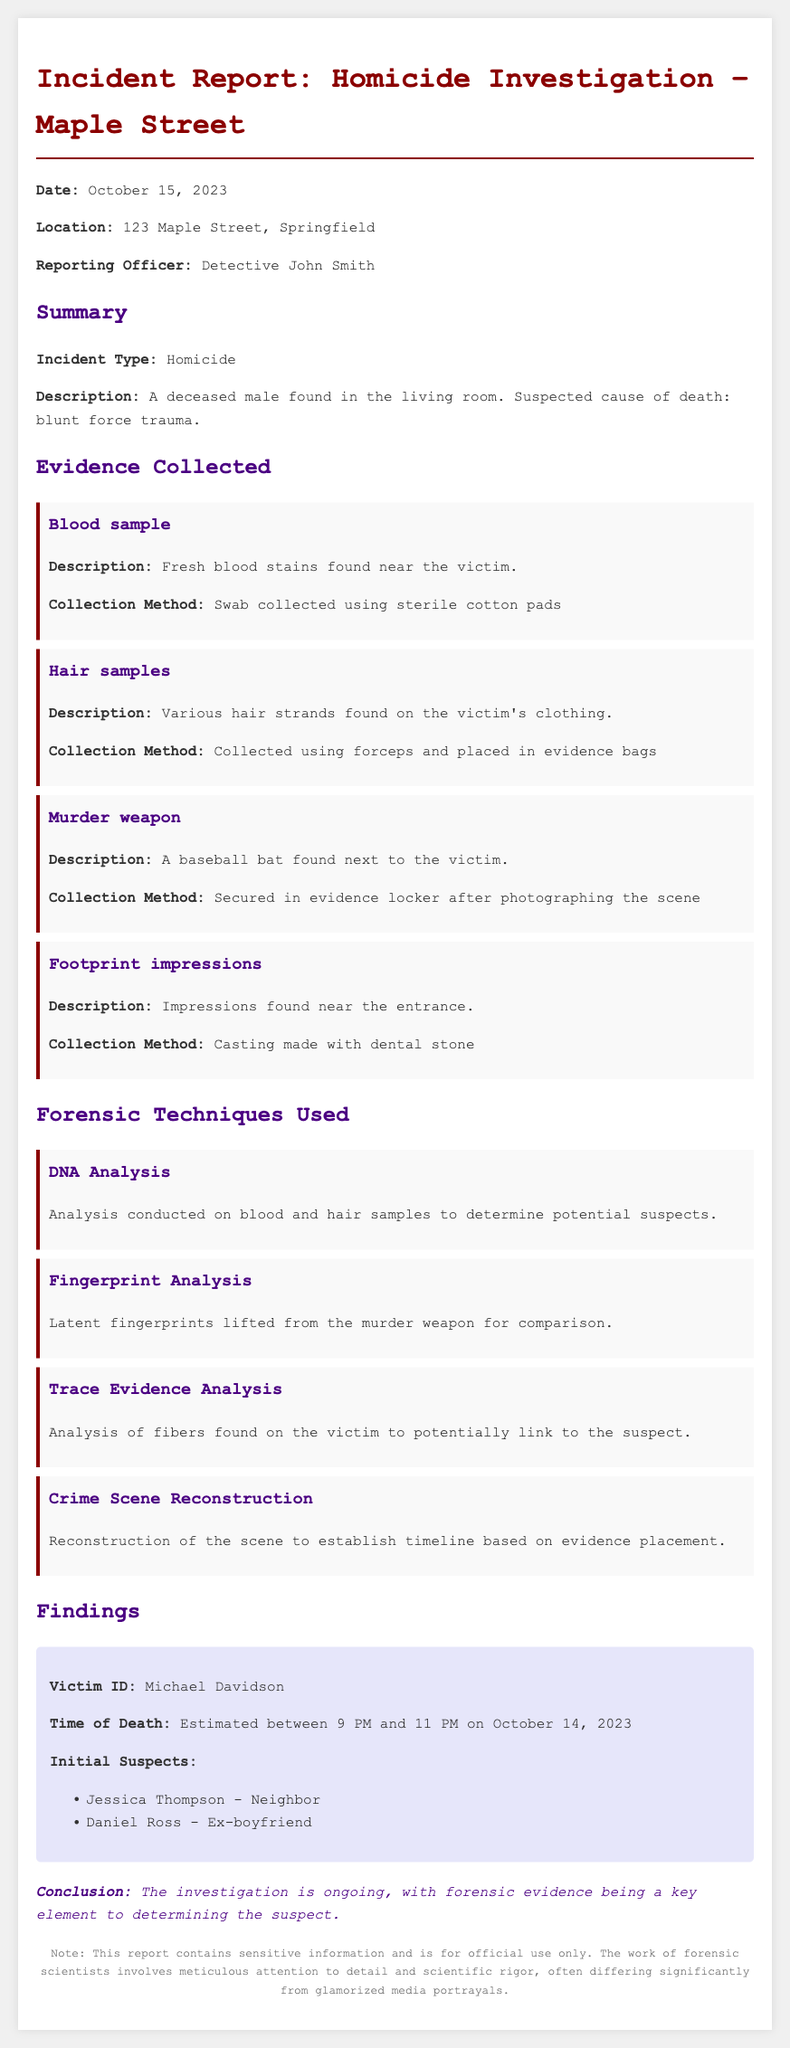What is the incident type? The incident type is classified in the document under Summary, labeled as "Incident Type."
Answer: Homicide What was the suspected cause of death? The suspected cause is detailed in the description of the incident in the Summary section.
Answer: Blunt force trauma Who is the victim identified in the findings? The findings section provides the name of the victim.
Answer: Michael Davidson What method was used to collect the blood sample? The method for collecting the blood sample is specified in the Evidence Collected section.
Answer: Swab collected using sterile cotton pads What forensic technique was used to analyze fibers found on the victim? The relevant forensic technique is mentioned in the Forensic Techniques Used section.
Answer: Trace Evidence Analysis Which two individuals were identified as initial suspects? The initial suspects are listed in the Findings section.
Answer: Jessica Thompson, Daniel Ross What was found next to the victim? The details about the murder weapon indicate what was found.
Answer: A baseball bat What was used to secure the murder weapon? The procedure for handling the murder weapon is described in the Evidence Collected section.
Answer: Secured in evidence locker after photographing the scene What is the time of death estimated to be? The time of death is provided in the Findings section of the report.
Answer: Between 9 PM and 11 PM on October 14, 2023 